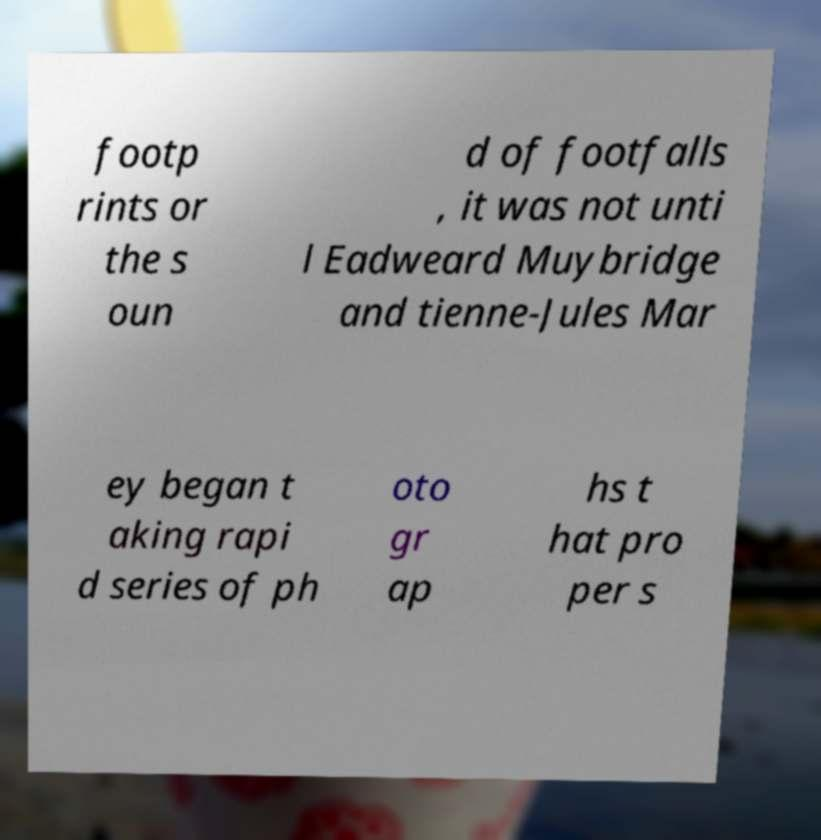For documentation purposes, I need the text within this image transcribed. Could you provide that? footp rints or the s oun d of footfalls , it was not unti l Eadweard Muybridge and tienne-Jules Mar ey began t aking rapi d series of ph oto gr ap hs t hat pro per s 